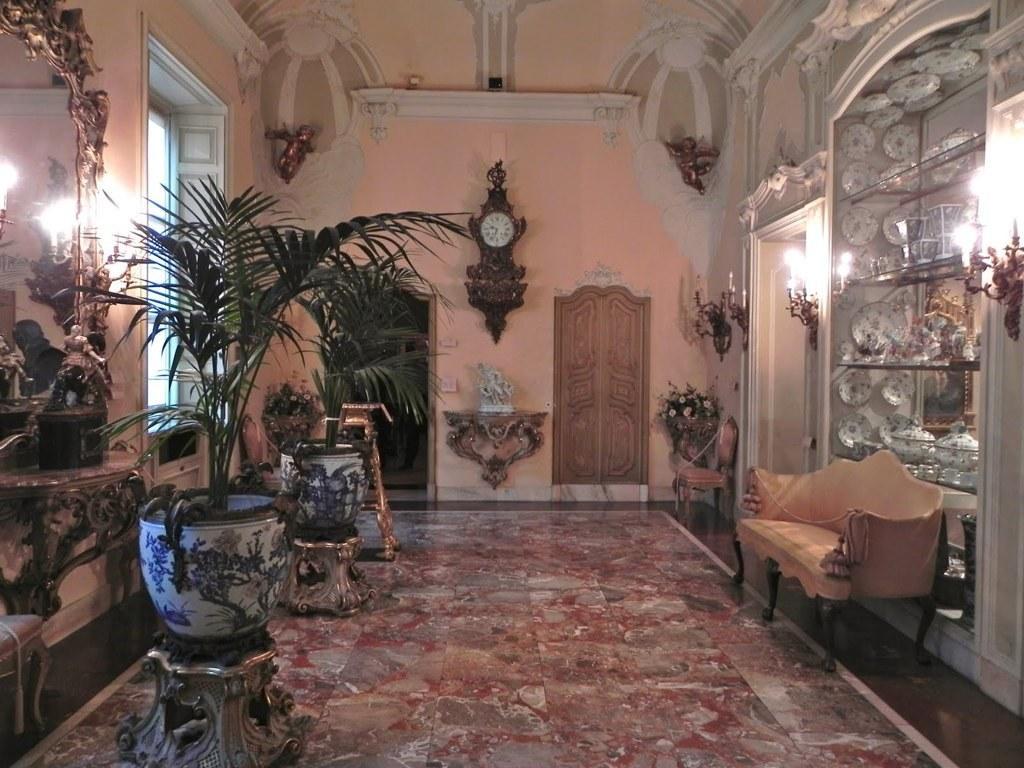How would you summarize this image in a sentence or two? In this image we can see inside view of a room with a wall clock on the wall, there are doors, statues to the wall, there is a chair, a sofa, few objects on the shelf and lights to the wall on the right side, there is a mirror, potted plants, a stool and an object near the mirror on the left side of the image. 